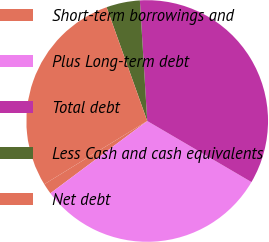Convert chart. <chart><loc_0><loc_0><loc_500><loc_500><pie_chart><fcel>Short-term borrowings and<fcel>Plus Long-term debt<fcel>Total debt<fcel>Less Cash and cash equivalents<fcel>Net debt<nl><fcel>1.44%<fcel>31.36%<fcel>34.41%<fcel>4.49%<fcel>28.31%<nl></chart> 